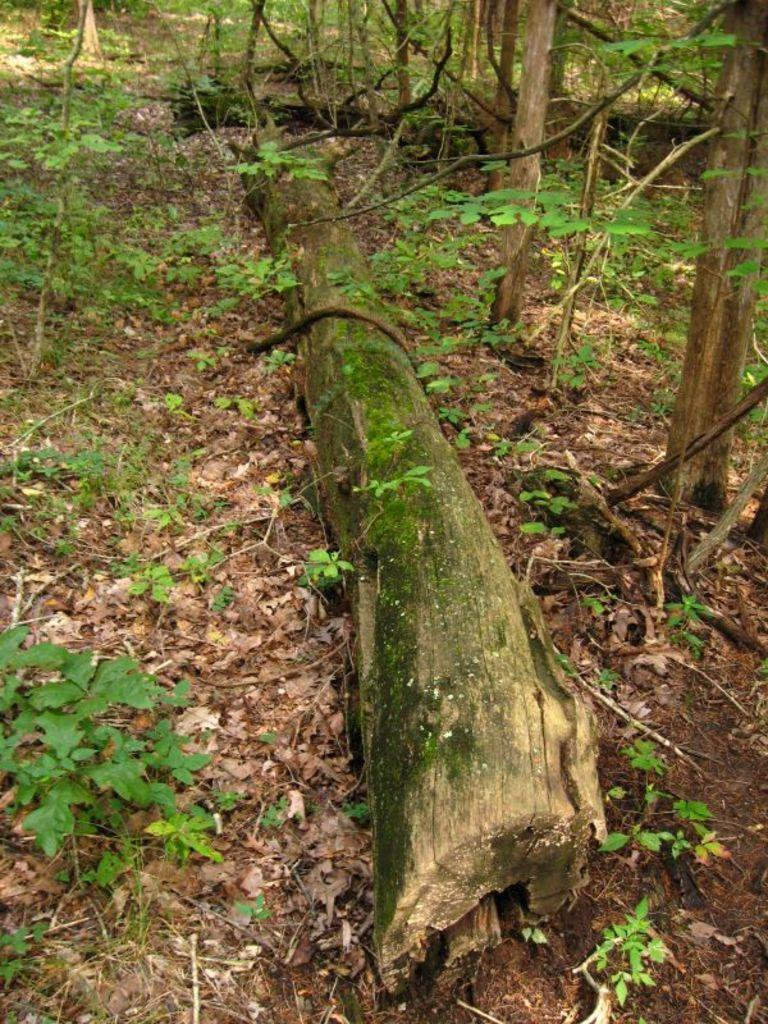What is on the ground in the image? There is tree bark on the ground in the image. What type of natural elements can be seen in the image? There are trees and plants visible in the image. What else can be found on the ground in the image? Leaves are present on the ground in the image. What type of art can be seen on the truck in the image? There is no truck present in the image, so no art can be seen on a truck. 